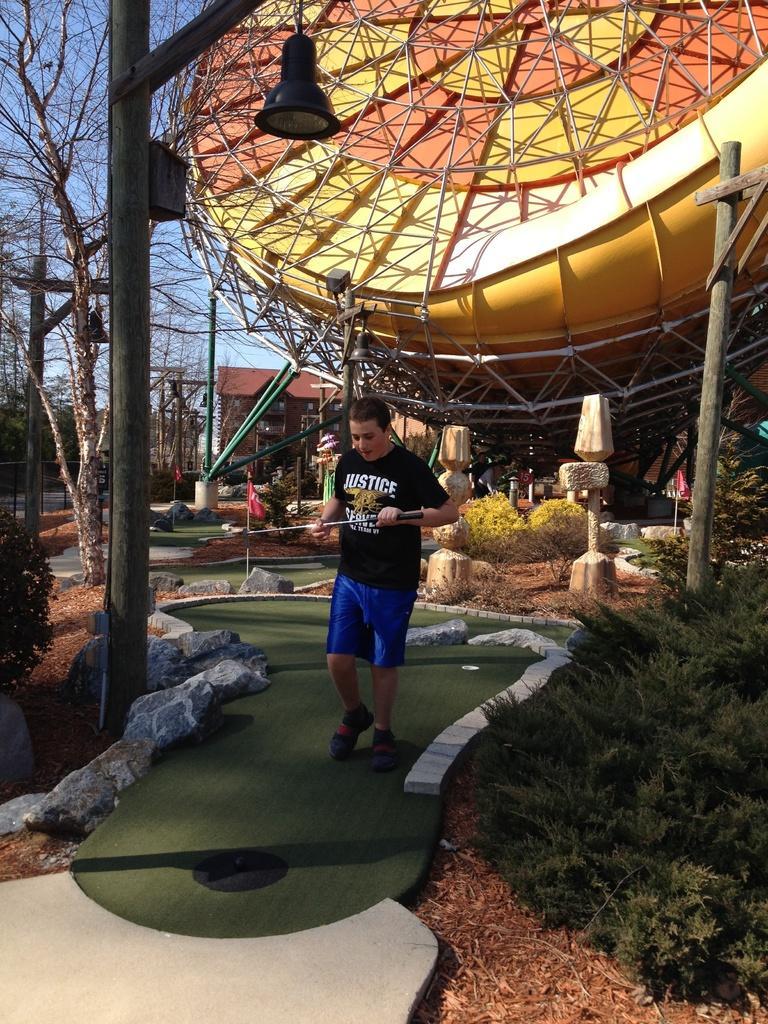Could you give a brief overview of what you see in this image? In the image a person is walking and carrying some object,we can see a lamp in the image and plants and trees are visible in the image. 